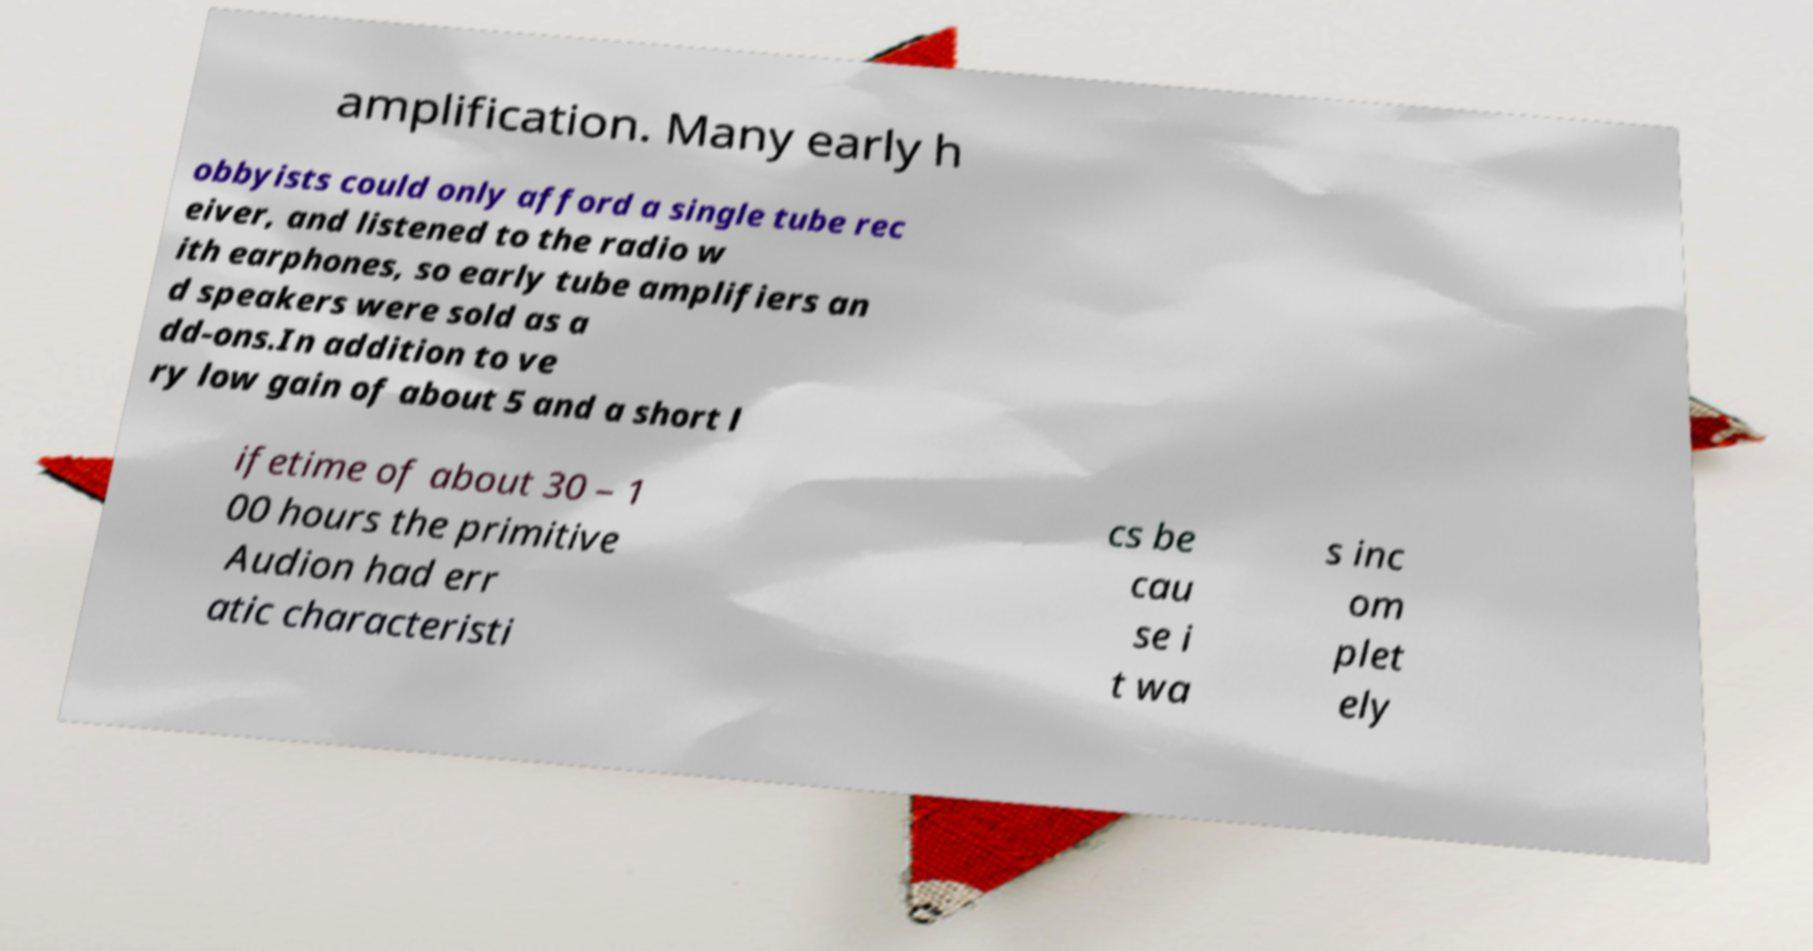Please identify and transcribe the text found in this image. amplification. Many early h obbyists could only afford a single tube rec eiver, and listened to the radio w ith earphones, so early tube amplifiers an d speakers were sold as a dd-ons.In addition to ve ry low gain of about 5 and a short l ifetime of about 30 – 1 00 hours the primitive Audion had err atic characteristi cs be cau se i t wa s inc om plet ely 